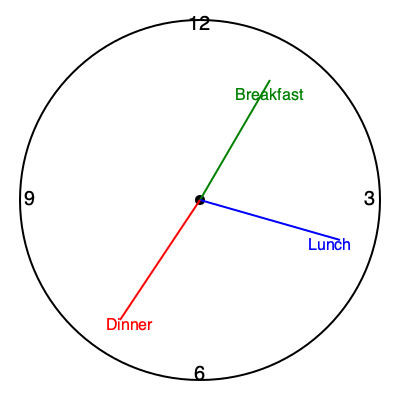Based on the 24-hour clock diagram showing meal timings, which eating pattern is most likely to promote optimal digestive health and why?

A) Breakfast at 7:30 AM, Lunch at 2:30 PM, Dinner at 8:00 PM
B) Breakfast at 9:00 AM, Lunch at 1:00 PM, Dinner at 5:00 PM
C) Breakfast at 6:00 AM, Lunch at 12:00 PM, Dinner at 6:00 PM
D) Breakfast at 8:00 AM, Lunch at 3:00 PM, Dinner at 9:00 PM To determine the optimal eating pattern for digestive health, we need to consider several factors:

1. Circadian rhythm: Our digestive system functions best when aligned with our body's natural circadian rhythm.

2. Meal spacing: Allowing sufficient time between meals helps complete digestion and promotes gut motility.

3. Night-time fasting: A longer overnight fasting period can improve gut health and metabolic function.

4. Last meal timing: Eating dinner earlier allows for better digestion before sleep.

Analyzing the options:

A) This pattern has irregular spacing and a late dinner, which may disrupt digestion during sleep.

B) This pattern has a shorter eating window, which may not allow enough time for proper digestion between meals.

C) This pattern aligns well with the body's circadian rhythm, provides even spacing between meals, and allows for a longer overnight fasting period.

D) This pattern has a late dinner, which may interfere with sleep and nighttime digestion.

Option C (Breakfast at 6:00 AM, Lunch at 12:00 PM, Dinner at 6:00 PM) is the most likely to promote optimal digestive health because:

1. It follows a 12-hour eating window, allowing for a 12-hour overnight fast.
2. Meals are evenly spaced 6 hours apart, providing sufficient time for digestion between meals.
3. The early dinner allows for complete digestion before bedtime, reducing the risk of acid reflux and promoting better sleep quality.
4. This pattern aligns well with the body's natural circadian rhythm, optimizing digestive enzyme production and gut motility.
Answer: C) Breakfast at 6:00 AM, Lunch at 12:00 PM, Dinner at 6:00 PM 